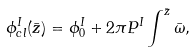<formula> <loc_0><loc_0><loc_500><loc_500>\phi ^ { I } _ { c l } ( \bar { z } ) = \phi ^ { I } _ { 0 } + 2 \pi P ^ { I } \int ^ { \bar { z } } \bar { \omega } ,</formula> 